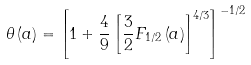Convert formula to latex. <formula><loc_0><loc_0><loc_500><loc_500>\theta \left ( a \right ) = \left [ 1 + \frac { 4 } { 9 } \left [ \frac { 3 } { 2 } F _ { 1 / 2 } \left ( a \right ) \right ] ^ { 4 / 3 } \right ] ^ { - 1 / 2 }</formula> 